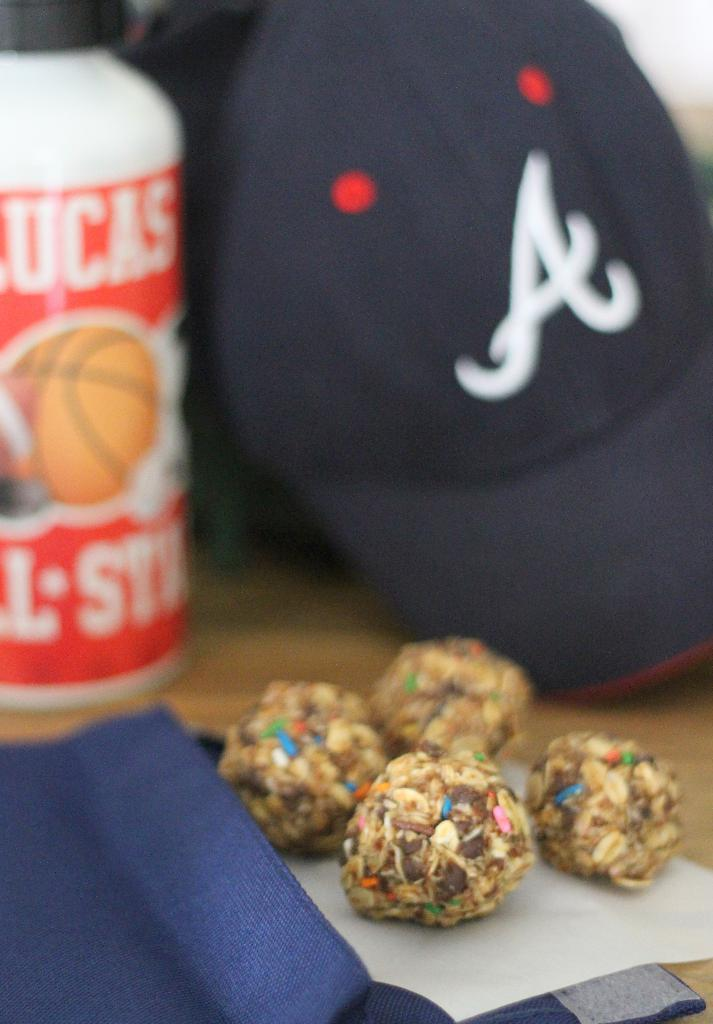What type of food can be seen in the image? The image contains food, but the specific type cannot be determined from the provided facts. What is the cap associated with in the image? The cap is associated with a bottle in the image. What other objects are present on the surface in the image? There are other objects on the surface in the image, but their specific nature cannot be determined from the provided facts. How many quarters can be seen in the image? There is no mention of quarters in the provided facts, so it cannot be determined if any are present in the image. 